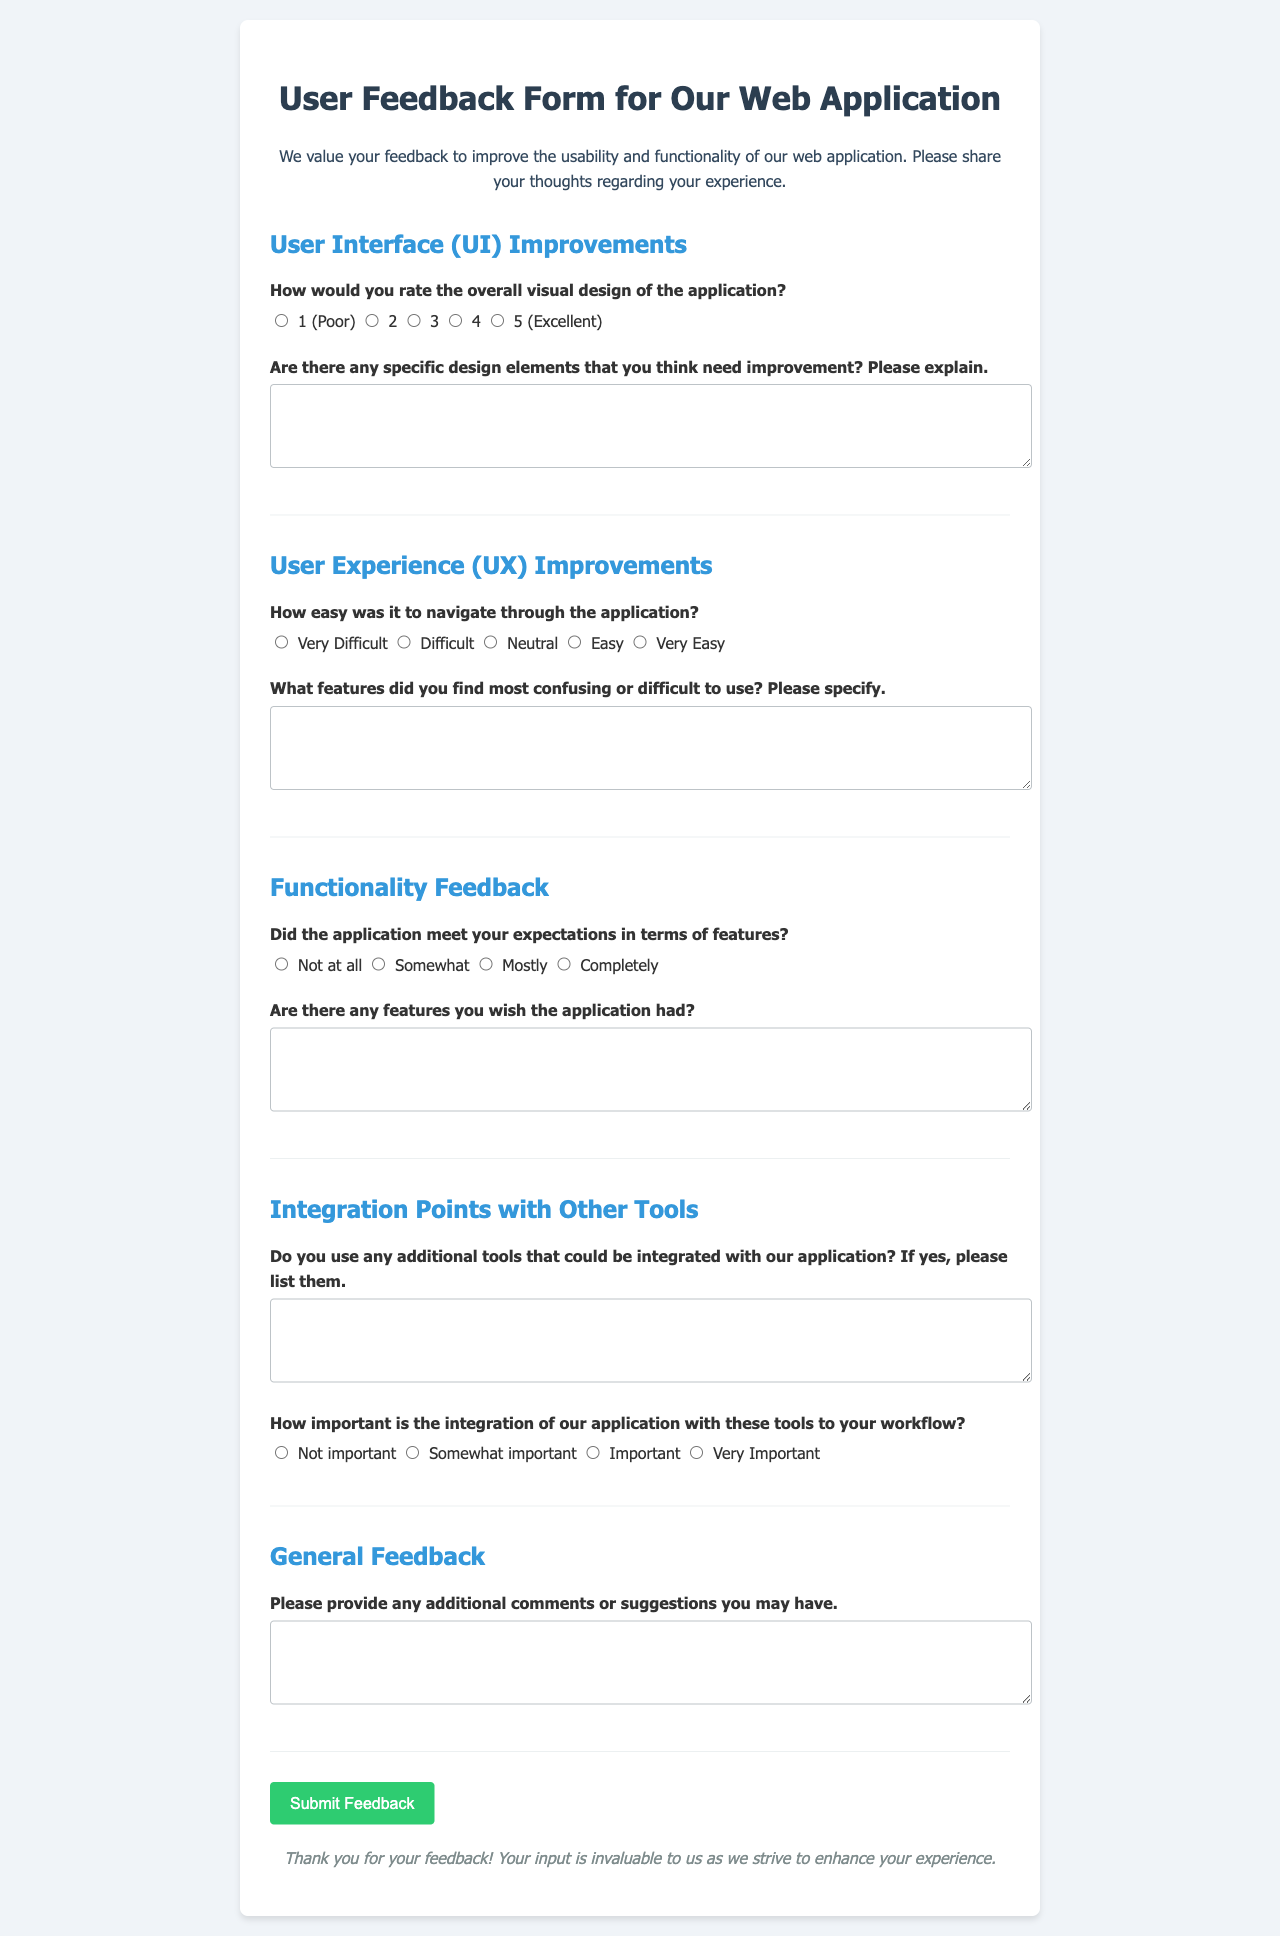What is the title of the feedback form? The title of the feedback form is specified in the heading of the document.
Answer: User Feedback Form for Our Web Application How many main sections are there in the form? The document lists the main sections of the form, which divide the feedback into categories.
Answer: 5 What color is the background of the form container? The background color of the form container is indicated in the CSS style definitions.
Answer: White What is the maximum visual design rating a user can give? The rating options provided indicate the maximum score for visual design in the feedback form.
Answer: 5 What is one of the specific topics users are asked about regarding user experience? The document outlines various topics to be covered in user feedback regarding user experience.
Answer: Navigation ease What feature do users need to specify that they find confusing? The feedback document requests details about specific features users may struggle with.
Answer: Features they find confusing How is the feedback form submitted? The document mentions specific actions taken when the feedback form is submitted.
Answer: Button click What is requested in the section on integration points? There is a specific request for information regarding additional tools users might be using related to the application.
Answer: Any additional tools What style is applied to the button when hovered over? The document specifies the visual change applied to the button when hovered over.
Answer: Darker green background 